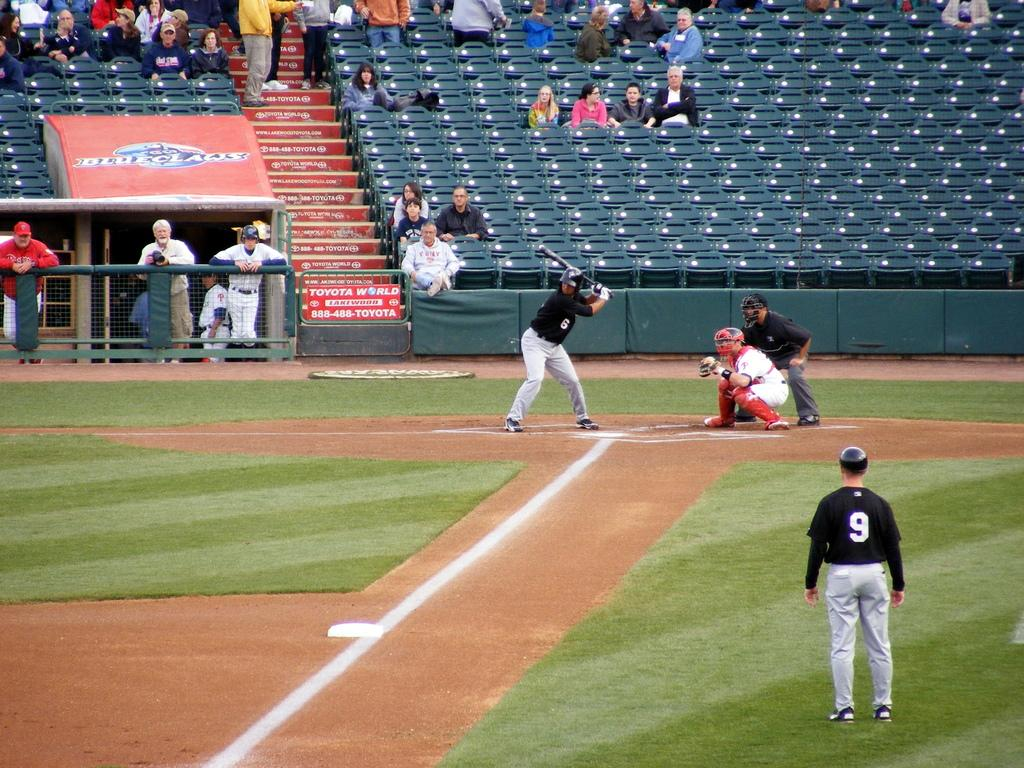<image>
Offer a succinct explanation of the picture presented. number 9 player is watching his teammate batting 